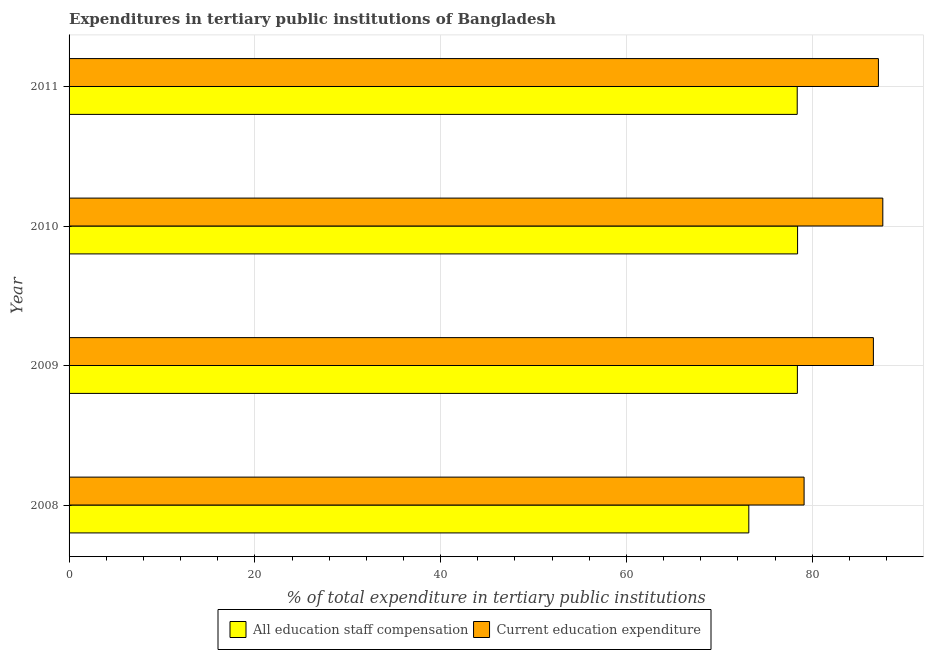How many different coloured bars are there?
Give a very brief answer. 2. In how many cases, is the number of bars for a given year not equal to the number of legend labels?
Your answer should be compact. 0. What is the expenditure in staff compensation in 2008?
Provide a short and direct response. 73.17. Across all years, what is the maximum expenditure in staff compensation?
Ensure brevity in your answer.  78.42. Across all years, what is the minimum expenditure in staff compensation?
Ensure brevity in your answer.  73.17. In which year was the expenditure in education minimum?
Your response must be concise. 2008. What is the total expenditure in education in the graph?
Your response must be concise. 340.41. What is the difference between the expenditure in education in 2009 and that in 2011?
Provide a short and direct response. -0.54. What is the difference between the expenditure in staff compensation in 2008 and the expenditure in education in 2010?
Give a very brief answer. -14.42. What is the average expenditure in staff compensation per year?
Your response must be concise. 77.09. In the year 2009, what is the difference between the expenditure in education and expenditure in staff compensation?
Provide a succinct answer. 8.18. In how many years, is the expenditure in staff compensation greater than 44 %?
Make the answer very short. 4. What is the ratio of the expenditure in staff compensation in 2008 to that in 2011?
Your answer should be compact. 0.93. Is the difference between the expenditure in education in 2008 and 2009 greater than the difference between the expenditure in staff compensation in 2008 and 2009?
Ensure brevity in your answer.  No. What is the difference between the highest and the second highest expenditure in education?
Give a very brief answer. 0.47. What is the difference between the highest and the lowest expenditure in staff compensation?
Keep it short and to the point. 5.25. In how many years, is the expenditure in staff compensation greater than the average expenditure in staff compensation taken over all years?
Keep it short and to the point. 3. What does the 1st bar from the top in 2008 represents?
Ensure brevity in your answer.  Current education expenditure. What does the 1st bar from the bottom in 2009 represents?
Offer a terse response. All education staff compensation. How many bars are there?
Keep it short and to the point. 8. Are all the bars in the graph horizontal?
Provide a short and direct response. Yes. What is the difference between two consecutive major ticks on the X-axis?
Ensure brevity in your answer.  20. Are the values on the major ticks of X-axis written in scientific E-notation?
Your answer should be compact. No. How are the legend labels stacked?
Make the answer very short. Horizontal. What is the title of the graph?
Your answer should be compact. Expenditures in tertiary public institutions of Bangladesh. Does "Investments" appear as one of the legend labels in the graph?
Your response must be concise. No. What is the label or title of the X-axis?
Make the answer very short. % of total expenditure in tertiary public institutions. What is the label or title of the Y-axis?
Provide a short and direct response. Year. What is the % of total expenditure in tertiary public institutions of All education staff compensation in 2008?
Ensure brevity in your answer.  73.17. What is the % of total expenditure in tertiary public institutions of Current education expenditure in 2008?
Your response must be concise. 79.12. What is the % of total expenditure in tertiary public institutions of All education staff compensation in 2009?
Give a very brief answer. 78.4. What is the % of total expenditure in tertiary public institutions in Current education expenditure in 2009?
Your answer should be very brief. 86.58. What is the % of total expenditure in tertiary public institutions in All education staff compensation in 2010?
Provide a succinct answer. 78.42. What is the % of total expenditure in tertiary public institutions of Current education expenditure in 2010?
Your response must be concise. 87.59. What is the % of total expenditure in tertiary public institutions of All education staff compensation in 2011?
Keep it short and to the point. 78.38. What is the % of total expenditure in tertiary public institutions in Current education expenditure in 2011?
Your answer should be very brief. 87.12. Across all years, what is the maximum % of total expenditure in tertiary public institutions of All education staff compensation?
Provide a succinct answer. 78.42. Across all years, what is the maximum % of total expenditure in tertiary public institutions of Current education expenditure?
Keep it short and to the point. 87.59. Across all years, what is the minimum % of total expenditure in tertiary public institutions of All education staff compensation?
Your answer should be compact. 73.17. Across all years, what is the minimum % of total expenditure in tertiary public institutions of Current education expenditure?
Provide a succinct answer. 79.12. What is the total % of total expenditure in tertiary public institutions of All education staff compensation in the graph?
Provide a short and direct response. 308.37. What is the total % of total expenditure in tertiary public institutions of Current education expenditure in the graph?
Give a very brief answer. 340.41. What is the difference between the % of total expenditure in tertiary public institutions in All education staff compensation in 2008 and that in 2009?
Offer a very short reply. -5.23. What is the difference between the % of total expenditure in tertiary public institutions in Current education expenditure in 2008 and that in 2009?
Offer a terse response. -7.46. What is the difference between the % of total expenditure in tertiary public institutions of All education staff compensation in 2008 and that in 2010?
Offer a terse response. -5.25. What is the difference between the % of total expenditure in tertiary public institutions in Current education expenditure in 2008 and that in 2010?
Provide a succinct answer. -8.47. What is the difference between the % of total expenditure in tertiary public institutions of All education staff compensation in 2008 and that in 2011?
Offer a terse response. -5.21. What is the difference between the % of total expenditure in tertiary public institutions of Current education expenditure in 2008 and that in 2011?
Offer a very short reply. -8. What is the difference between the % of total expenditure in tertiary public institutions in All education staff compensation in 2009 and that in 2010?
Offer a very short reply. -0.02. What is the difference between the % of total expenditure in tertiary public institutions in Current education expenditure in 2009 and that in 2010?
Offer a very short reply. -1.01. What is the difference between the % of total expenditure in tertiary public institutions of All education staff compensation in 2009 and that in 2011?
Offer a terse response. 0.02. What is the difference between the % of total expenditure in tertiary public institutions of Current education expenditure in 2009 and that in 2011?
Your answer should be very brief. -0.54. What is the difference between the % of total expenditure in tertiary public institutions of All education staff compensation in 2010 and that in 2011?
Make the answer very short. 0.04. What is the difference between the % of total expenditure in tertiary public institutions of Current education expenditure in 2010 and that in 2011?
Give a very brief answer. 0.47. What is the difference between the % of total expenditure in tertiary public institutions of All education staff compensation in 2008 and the % of total expenditure in tertiary public institutions of Current education expenditure in 2009?
Your response must be concise. -13.41. What is the difference between the % of total expenditure in tertiary public institutions in All education staff compensation in 2008 and the % of total expenditure in tertiary public institutions in Current education expenditure in 2010?
Your answer should be very brief. -14.42. What is the difference between the % of total expenditure in tertiary public institutions of All education staff compensation in 2008 and the % of total expenditure in tertiary public institutions of Current education expenditure in 2011?
Offer a very short reply. -13.95. What is the difference between the % of total expenditure in tertiary public institutions in All education staff compensation in 2009 and the % of total expenditure in tertiary public institutions in Current education expenditure in 2010?
Your answer should be very brief. -9.2. What is the difference between the % of total expenditure in tertiary public institutions of All education staff compensation in 2009 and the % of total expenditure in tertiary public institutions of Current education expenditure in 2011?
Offer a very short reply. -8.72. What is the difference between the % of total expenditure in tertiary public institutions of All education staff compensation in 2010 and the % of total expenditure in tertiary public institutions of Current education expenditure in 2011?
Offer a very short reply. -8.7. What is the average % of total expenditure in tertiary public institutions in All education staff compensation per year?
Keep it short and to the point. 77.09. What is the average % of total expenditure in tertiary public institutions of Current education expenditure per year?
Ensure brevity in your answer.  85.1. In the year 2008, what is the difference between the % of total expenditure in tertiary public institutions in All education staff compensation and % of total expenditure in tertiary public institutions in Current education expenditure?
Your response must be concise. -5.95. In the year 2009, what is the difference between the % of total expenditure in tertiary public institutions in All education staff compensation and % of total expenditure in tertiary public institutions in Current education expenditure?
Make the answer very short. -8.18. In the year 2010, what is the difference between the % of total expenditure in tertiary public institutions of All education staff compensation and % of total expenditure in tertiary public institutions of Current education expenditure?
Keep it short and to the point. -9.17. In the year 2011, what is the difference between the % of total expenditure in tertiary public institutions in All education staff compensation and % of total expenditure in tertiary public institutions in Current education expenditure?
Provide a short and direct response. -8.74. What is the ratio of the % of total expenditure in tertiary public institutions of All education staff compensation in 2008 to that in 2009?
Your response must be concise. 0.93. What is the ratio of the % of total expenditure in tertiary public institutions in Current education expenditure in 2008 to that in 2009?
Give a very brief answer. 0.91. What is the ratio of the % of total expenditure in tertiary public institutions in All education staff compensation in 2008 to that in 2010?
Your response must be concise. 0.93. What is the ratio of the % of total expenditure in tertiary public institutions in Current education expenditure in 2008 to that in 2010?
Offer a very short reply. 0.9. What is the ratio of the % of total expenditure in tertiary public institutions of All education staff compensation in 2008 to that in 2011?
Ensure brevity in your answer.  0.93. What is the ratio of the % of total expenditure in tertiary public institutions of Current education expenditure in 2008 to that in 2011?
Offer a very short reply. 0.91. What is the ratio of the % of total expenditure in tertiary public institutions of Current education expenditure in 2009 to that in 2010?
Keep it short and to the point. 0.99. What is the ratio of the % of total expenditure in tertiary public institutions of All education staff compensation in 2009 to that in 2011?
Provide a succinct answer. 1. What is the ratio of the % of total expenditure in tertiary public institutions in Current education expenditure in 2009 to that in 2011?
Your response must be concise. 0.99. What is the ratio of the % of total expenditure in tertiary public institutions in All education staff compensation in 2010 to that in 2011?
Ensure brevity in your answer.  1. What is the ratio of the % of total expenditure in tertiary public institutions of Current education expenditure in 2010 to that in 2011?
Offer a terse response. 1.01. What is the difference between the highest and the second highest % of total expenditure in tertiary public institutions of All education staff compensation?
Provide a succinct answer. 0.02. What is the difference between the highest and the second highest % of total expenditure in tertiary public institutions in Current education expenditure?
Provide a short and direct response. 0.47. What is the difference between the highest and the lowest % of total expenditure in tertiary public institutions in All education staff compensation?
Your answer should be very brief. 5.25. What is the difference between the highest and the lowest % of total expenditure in tertiary public institutions of Current education expenditure?
Provide a succinct answer. 8.47. 